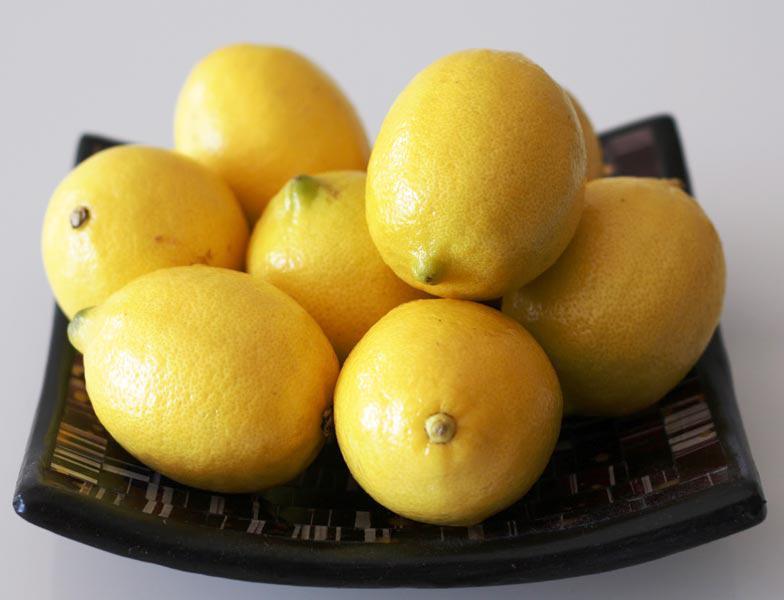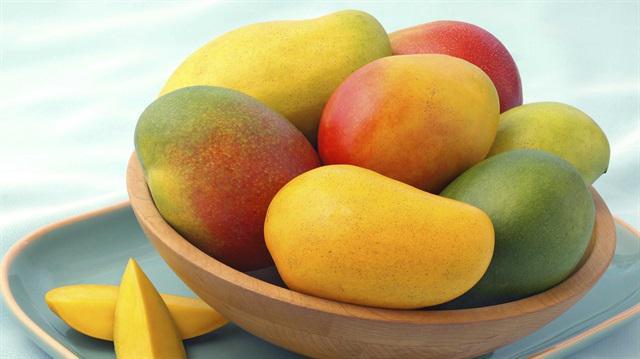The first image is the image on the left, the second image is the image on the right. Given the left and right images, does the statement "There are only whole uncut lemons in the left image." hold true? Answer yes or no. Yes. The first image is the image on the left, the second image is the image on the right. Examine the images to the left and right. Is the description "The combined images include at least one cut lemon half and multiple whole lemons, but no lemons are in a container." accurate? Answer yes or no. No. 